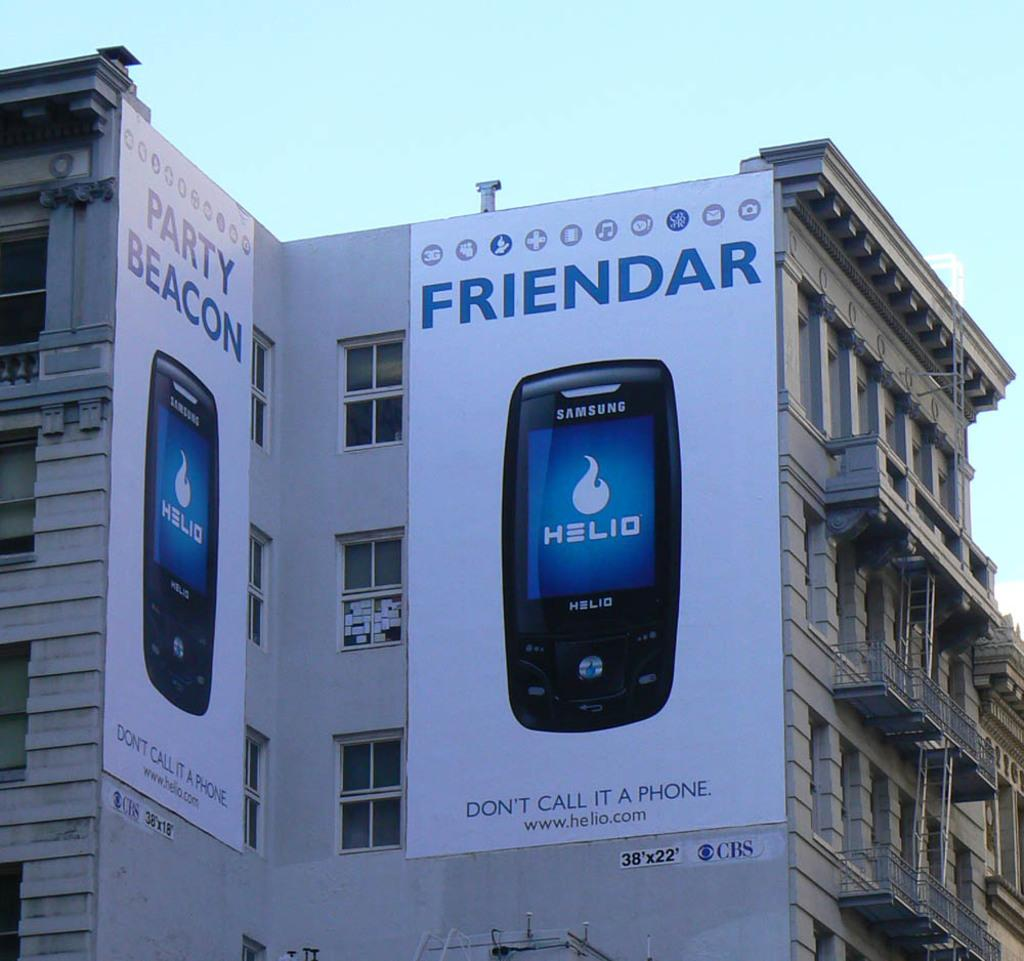<image>
Give a short and clear explanation of the subsequent image. Ads for Helio say to not call it a phone. 